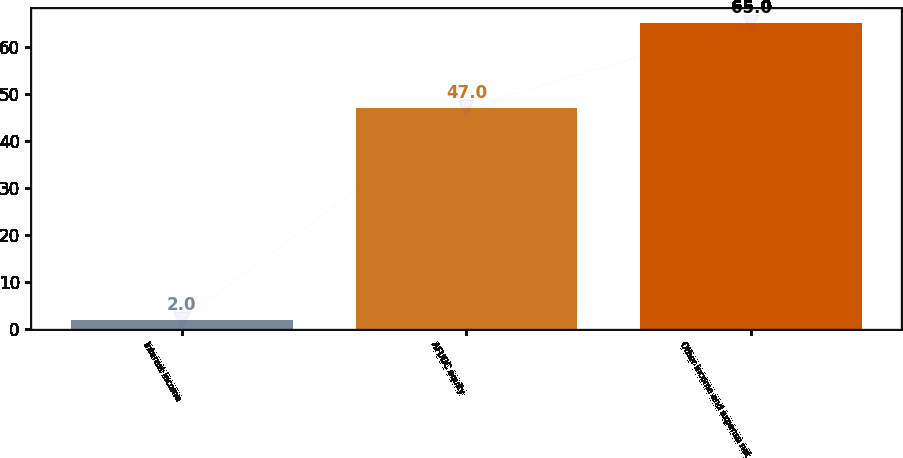<chart> <loc_0><loc_0><loc_500><loc_500><bar_chart><fcel>Interest income<fcel>AFUDC equity<fcel>Other income and expense net<nl><fcel>2<fcel>47<fcel>65<nl></chart> 